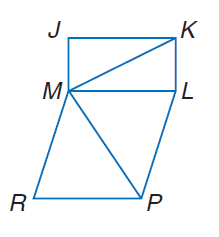Answer the mathemtical geometry problem and directly provide the correct option letter.
Question: J K L M is a rectangle. M L P R is a rhombus. \angle J M K \cong \angle R M P, m \angle J M K = 55 and m \angle M R P = 70. Find m \angle M P R.
Choices: A: 55 B: 70 C: 125 D: 250 A 